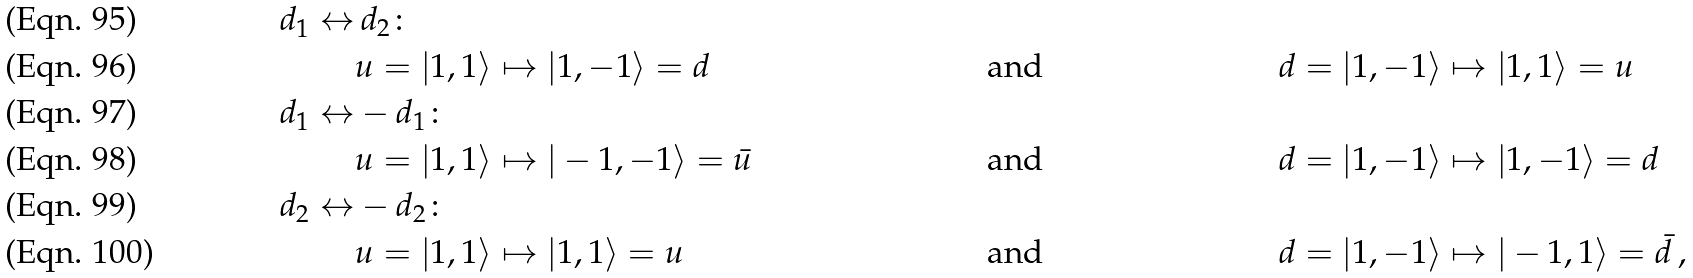<formula> <loc_0><loc_0><loc_500><loc_500>d _ { 1 } \leftrightarrow & \, d _ { 2 } \colon \\ & u = | 1 , 1 \rangle \mapsto | 1 , - 1 \rangle = d & & \text {and} & & d = | 1 , - 1 \rangle \mapsto | 1 , 1 \rangle = u \\ d _ { 1 } \leftrightarrow & - d _ { 1 } \colon \\ & u = | 1 , 1 \rangle \mapsto | - 1 , - 1 \rangle = \bar { u } \quad & & \text {and} \quad & & d = | 1 , - 1 \rangle \mapsto | 1 , - 1 \rangle = d \\ d _ { 2 } \leftrightarrow & - d _ { 2 } \colon \\ & u = | 1 , 1 \rangle \mapsto | 1 , 1 \rangle = u & & \text {and} & & d = | 1 , - 1 \rangle \mapsto | - 1 , 1 \rangle = \bar { d } \, ,</formula> 